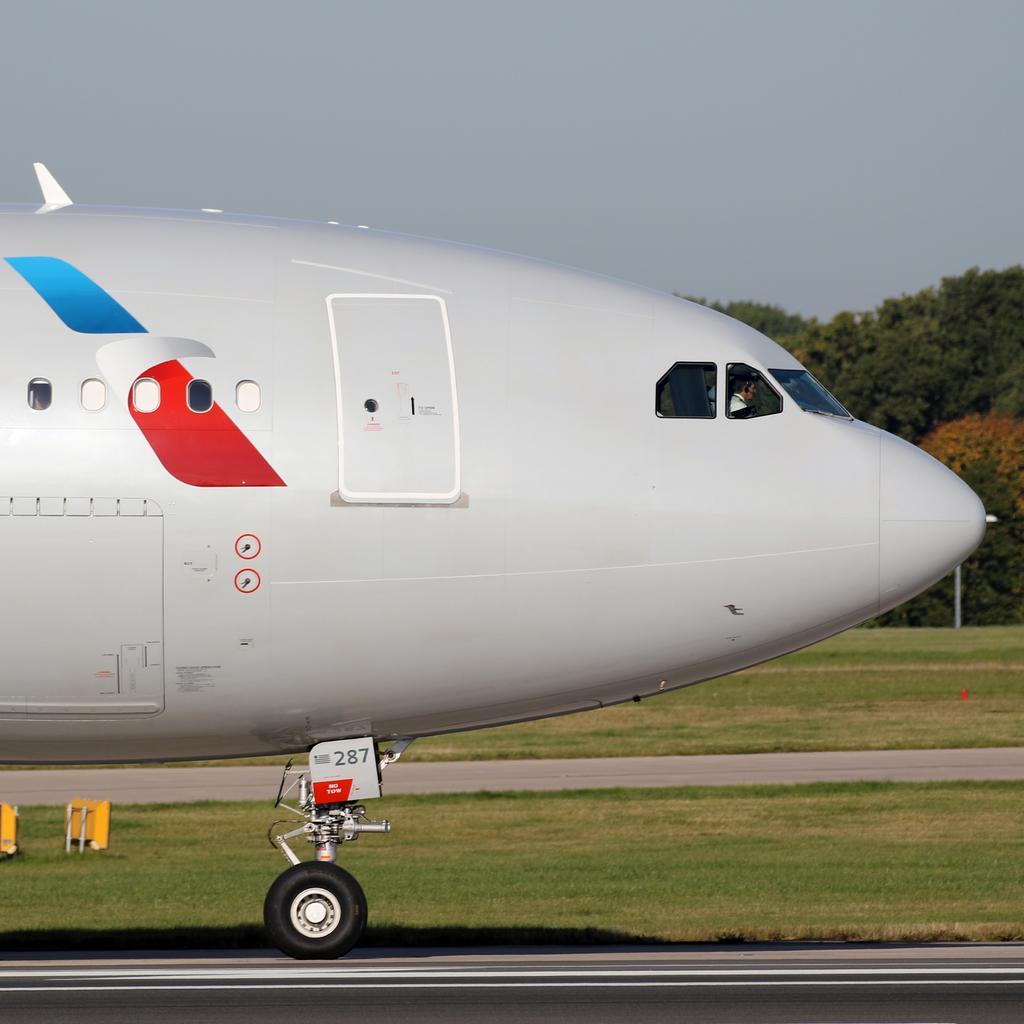Please provide a concise description of this image. In this picture we can see an airplane and a person is seated in it, in the background we can see grass few trees and a pole. 